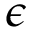Convert formula to latex. <formula><loc_0><loc_0><loc_500><loc_500>\epsilon</formula> 